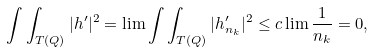Convert formula to latex. <formula><loc_0><loc_0><loc_500><loc_500>\int \int _ { T ( Q ) } | h ^ { \prime } | ^ { 2 } & = \lim \int \int _ { T ( Q ) } | h _ { n _ { k } } ^ { \prime } | ^ { 2 } \leq c \lim \frac { 1 } { n _ { k } } = 0 ,</formula> 